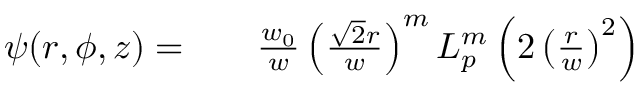Convert formula to latex. <formula><loc_0><loc_0><loc_500><loc_500>\begin{array} { r l r } { \psi ( r , \phi , z ) = } & { \frac { w _ { 0 } } { w } \left ( \frac { \sqrt { 2 } r } { w } \right ) ^ { m } L _ { p } ^ { m } \left ( 2 \left ( \frac { r } { w } \right ) ^ { 2 } \right ) } \end{array}</formula> 